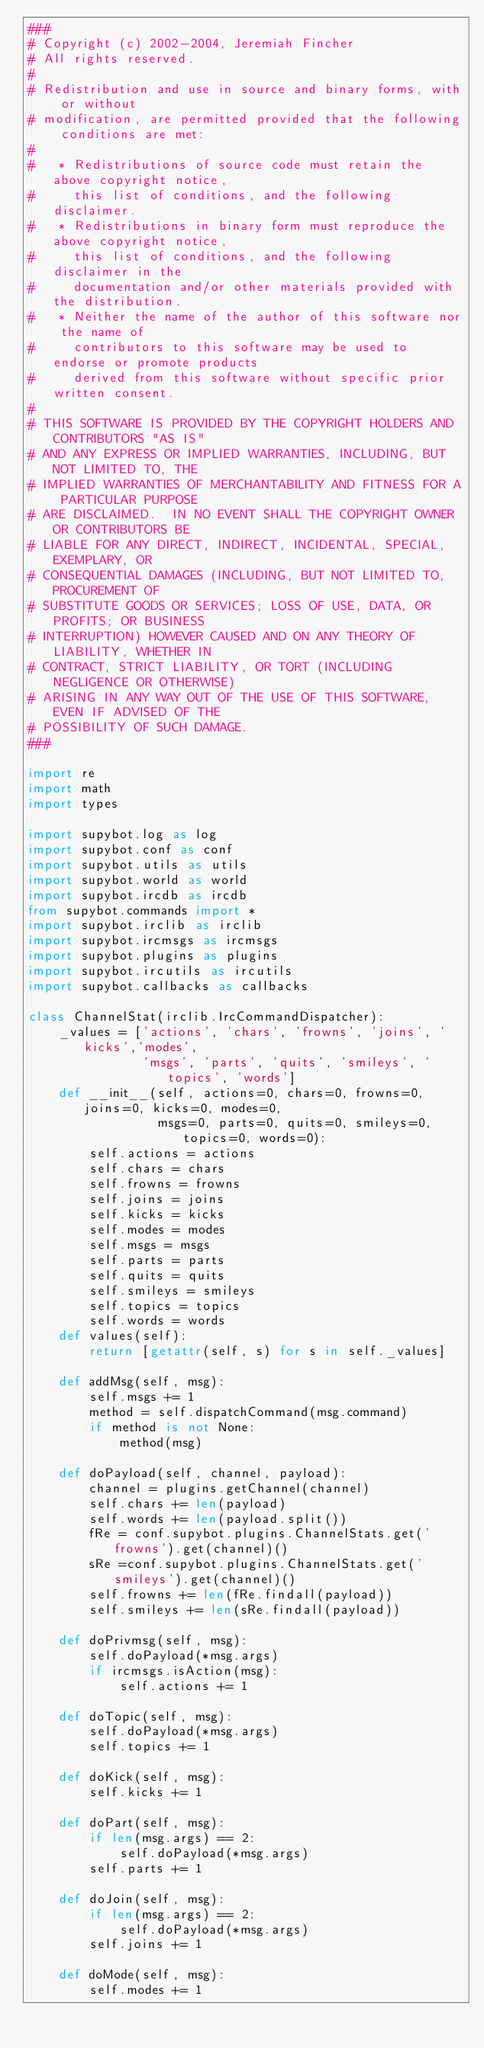Convert code to text. <code><loc_0><loc_0><loc_500><loc_500><_Python_>###
# Copyright (c) 2002-2004, Jeremiah Fincher
# All rights reserved.
#
# Redistribution and use in source and binary forms, with or without
# modification, are permitted provided that the following conditions are met:
#
#   * Redistributions of source code must retain the above copyright notice,
#     this list of conditions, and the following disclaimer.
#   * Redistributions in binary form must reproduce the above copyright notice,
#     this list of conditions, and the following disclaimer in the
#     documentation and/or other materials provided with the distribution.
#   * Neither the name of the author of this software nor the name of
#     contributors to this software may be used to endorse or promote products
#     derived from this software without specific prior written consent.
#
# THIS SOFTWARE IS PROVIDED BY THE COPYRIGHT HOLDERS AND CONTRIBUTORS "AS IS"
# AND ANY EXPRESS OR IMPLIED WARRANTIES, INCLUDING, BUT NOT LIMITED TO, THE
# IMPLIED WARRANTIES OF MERCHANTABILITY AND FITNESS FOR A PARTICULAR PURPOSE
# ARE DISCLAIMED.  IN NO EVENT SHALL THE COPYRIGHT OWNER OR CONTRIBUTORS BE
# LIABLE FOR ANY DIRECT, INDIRECT, INCIDENTAL, SPECIAL, EXEMPLARY, OR
# CONSEQUENTIAL DAMAGES (INCLUDING, BUT NOT LIMITED TO, PROCUREMENT OF
# SUBSTITUTE GOODS OR SERVICES; LOSS OF USE, DATA, OR PROFITS; OR BUSINESS
# INTERRUPTION) HOWEVER CAUSED AND ON ANY THEORY OF LIABILITY, WHETHER IN
# CONTRACT, STRICT LIABILITY, OR TORT (INCLUDING NEGLIGENCE OR OTHERWISE)
# ARISING IN ANY WAY OUT OF THE USE OF THIS SOFTWARE, EVEN IF ADVISED OF THE
# POSSIBILITY OF SUCH DAMAGE.
###

import re
import math
import types

import supybot.log as log
import supybot.conf as conf
import supybot.utils as utils
import supybot.world as world
import supybot.ircdb as ircdb
from supybot.commands import *
import supybot.irclib as irclib
import supybot.ircmsgs as ircmsgs
import supybot.plugins as plugins
import supybot.ircutils as ircutils
import supybot.callbacks as callbacks

class ChannelStat(irclib.IrcCommandDispatcher):
    _values = ['actions', 'chars', 'frowns', 'joins', 'kicks','modes',
               'msgs', 'parts', 'quits', 'smileys', 'topics', 'words']
    def __init__(self, actions=0, chars=0, frowns=0, joins=0, kicks=0, modes=0,
                 msgs=0, parts=0, quits=0, smileys=0, topics=0, words=0):
        self.actions = actions
        self.chars = chars
        self.frowns = frowns
        self.joins = joins
        self.kicks = kicks
        self.modes = modes
        self.msgs = msgs
        self.parts = parts
        self.quits = quits
        self.smileys = smileys
        self.topics = topics
        self.words = words
    def values(self):
        return [getattr(self, s) for s in self._values]

    def addMsg(self, msg):
        self.msgs += 1
        method = self.dispatchCommand(msg.command)
        if method is not None:
            method(msg)

    def doPayload(self, channel, payload):
        channel = plugins.getChannel(channel)
        self.chars += len(payload)
        self.words += len(payload.split())
        fRe = conf.supybot.plugins.ChannelStats.get('frowns').get(channel)()
        sRe =conf.supybot.plugins.ChannelStats.get('smileys').get(channel)()
        self.frowns += len(fRe.findall(payload))
        self.smileys += len(sRe.findall(payload))

    def doPrivmsg(self, msg):
        self.doPayload(*msg.args)
        if ircmsgs.isAction(msg):
            self.actions += 1

    def doTopic(self, msg):
        self.doPayload(*msg.args)
        self.topics += 1

    def doKick(self, msg):
        self.kicks += 1

    def doPart(self, msg):
        if len(msg.args) == 2:
            self.doPayload(*msg.args)
        self.parts += 1

    def doJoin(self, msg):
        if len(msg.args) == 2:
            self.doPayload(*msg.args)
        self.joins += 1

    def doMode(self, msg):
        self.modes += 1
</code> 